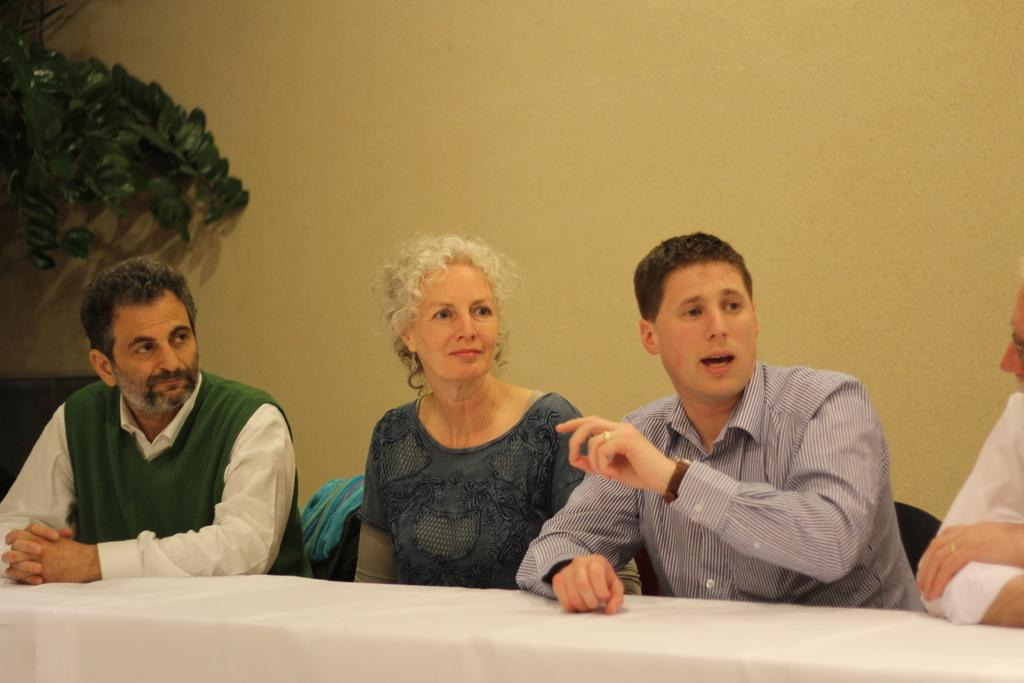What are the people in the image doing? The people in the image are sitting on chairs. What is in front of the people? There is a table in front of the people. What can be seen on the right side of the image? There is a plant on the right side of the image. What is the background of the image? There is a wall in the image. Is there a volcano visible in the image? No, there is no volcano present in the image. Can you see a hill in the background of the image? No, there is no hill visible in the image. 